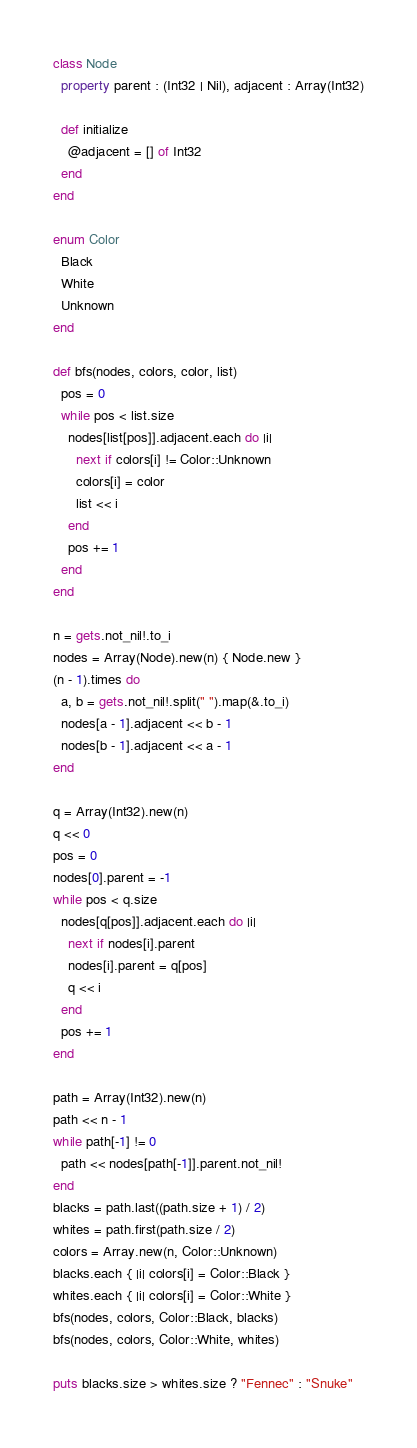<code> <loc_0><loc_0><loc_500><loc_500><_Crystal_>class Node
  property parent : (Int32 | Nil), adjacent : Array(Int32)

  def initialize
    @adjacent = [] of Int32
  end
end

enum Color
  Black
  White
  Unknown
end

def bfs(nodes, colors, color, list)
  pos = 0
  while pos < list.size
    nodes[list[pos]].adjacent.each do |i|
      next if colors[i] != Color::Unknown
      colors[i] = color
      list << i
    end
    pos += 1
  end
end

n = gets.not_nil!.to_i
nodes = Array(Node).new(n) { Node.new }
(n - 1).times do
  a, b = gets.not_nil!.split(" ").map(&.to_i)
  nodes[a - 1].adjacent << b - 1
  nodes[b - 1].adjacent << a - 1
end

q = Array(Int32).new(n)
q << 0
pos = 0
nodes[0].parent = -1
while pos < q.size
  nodes[q[pos]].adjacent.each do |i|
    next if nodes[i].parent
    nodes[i].parent = q[pos]
    q << i
  end
  pos += 1
end

path = Array(Int32).new(n)
path << n - 1
while path[-1] != 0
  path << nodes[path[-1]].parent.not_nil!
end
blacks = path.last((path.size + 1) / 2)
whites = path.first(path.size / 2)
colors = Array.new(n, Color::Unknown)
blacks.each { |i| colors[i] = Color::Black }
whites.each { |i| colors[i] = Color::White }
bfs(nodes, colors, Color::Black, blacks)
bfs(nodes, colors, Color::White, whites)

puts blacks.size > whites.size ? "Fennec" : "Snuke"
</code> 